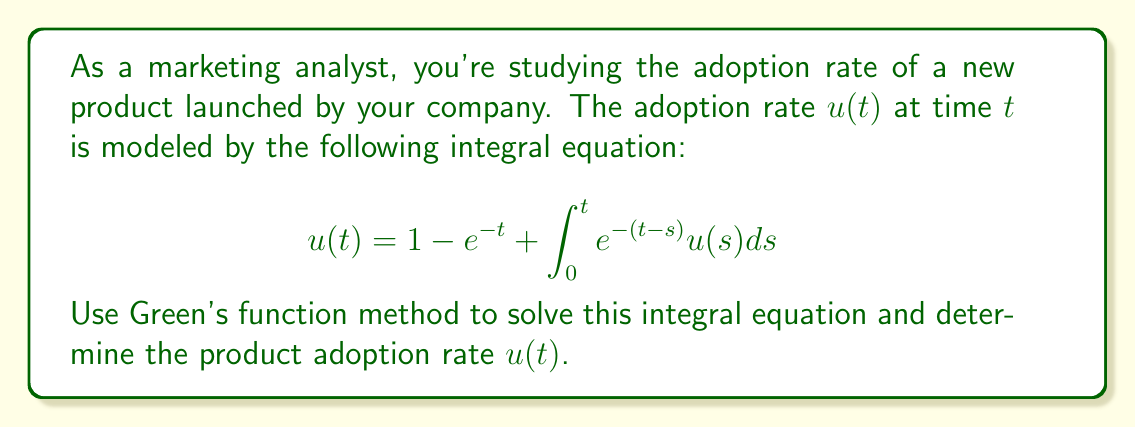Provide a solution to this math problem. Let's solve this integral equation using Green's function method:

1) First, we identify the kernel of the integral equation:
   $K(t,s) = e^{-(t-s)}$

2) The inhomogeneous term is:
   $f(t) = 1 - e^{-t}$

3) The Green's function $G(t,s)$ satisfies:
   $G(t,s) = K(t,s) + \int_s^t K(t,\tau)G(\tau,s)d\tau$

4) Substituting the kernel:
   $G(t,s) = e^{-(t-s)} + \int_s^t e^{-(t-\tau)}G(\tau,s)d\tau$

5) We guess that $G(t,s) = Ae^{-(t-s)}$, where $A$ is a constant.

6) Substituting this into the equation for $G(t,s)$:
   $Ae^{-(t-s)} = e^{-(t-s)} + \int_s^t e^{-(t-\tau)}Ae^{-(\tau-s)}d\tau$
   $Ae^{-(t-s)} = e^{-(t-s)} + Ae^{-t+s}(t-s)$

7) Equating coefficients:
   $A = 1 + A$
   $A = -1$

8) Therefore, $G(t,s) = -e^{-(t-s)}$

9) The solution is given by:
   $u(t) = f(t) - \int_0^t G(t,s)f(s)ds$

10) Substituting $f(t)$ and $G(t,s)$:
    $u(t) = 1 - e^{-t} + \int_0^t e^{-(t-s)}(1-e^{-s})ds$

11) Evaluating the integral:
    $u(t) = 1 - e^{-t} + [e^{-t}(e^s-1) - (1-e^{-s})]_0^t$
    $u(t) = 1 - e^{-t} + [(1-e^{-t}) - t]$

12) Simplifying:
    $u(t) = 2 - e^{-t} - t$
Answer: $u(t) = 2 - e^{-t} - t$ 